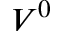Convert formula to latex. <formula><loc_0><loc_0><loc_500><loc_500>V ^ { 0 }</formula> 